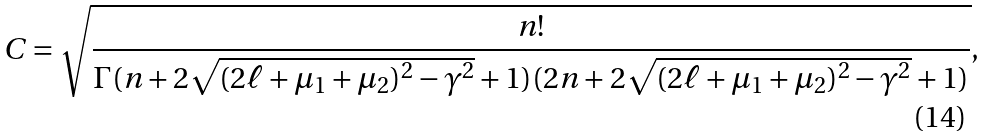<formula> <loc_0><loc_0><loc_500><loc_500>C = \sqrt { \frac { n ! } { \Gamma ( n + 2 \sqrt { ( 2 \ell + \mu _ { 1 } + \mu _ { 2 } ) ^ { 2 } - \gamma ^ { 2 } } + 1 ) ( 2 n + 2 \sqrt { ( 2 \ell + \mu _ { 1 } + \mu _ { 2 } ) ^ { 2 } - \gamma ^ { 2 } } + 1 ) } } ,</formula> 